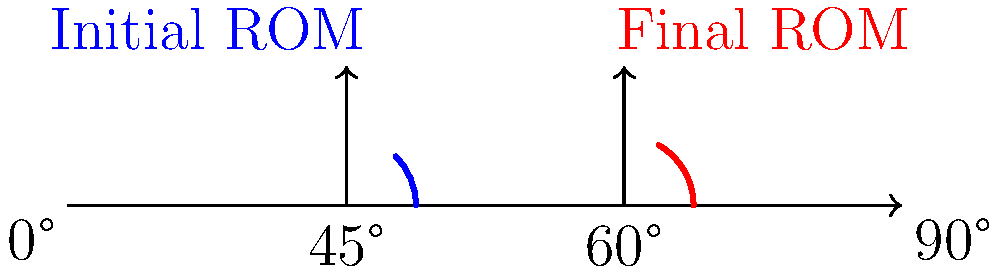A client with a shoulder injury initially had a range of motion (ROM) of 45° in shoulder flexion. After 8 weeks of rehabilitation, their ROM improved to 60°. Using the goniometer measurements represented in the angle diagram, calculate the percentage improvement in the client's shoulder flexion ROM. Round your answer to the nearest whole percent. To calculate the percentage improvement in the client's shoulder flexion ROM, we'll follow these steps:

1. Identify the initial and final ROM:
   Initial ROM = 45°
   Final ROM = 60°

2. Calculate the absolute improvement:
   Improvement = Final ROM - Initial ROM
   Improvement = 60° - 45° = 15°

3. Calculate the percentage improvement:
   Percentage improvement = (Improvement / Initial ROM) × 100
   Percentage improvement = (15° / 45°) × 100

4. Perform the calculation:
   Percentage improvement = 0.3333... × 100 = 33.33...%

5. Round to the nearest whole percent:
   33.33...% rounds to 33%

Therefore, the client's shoulder flexion ROM improved by approximately 33%.
Answer: 33% 